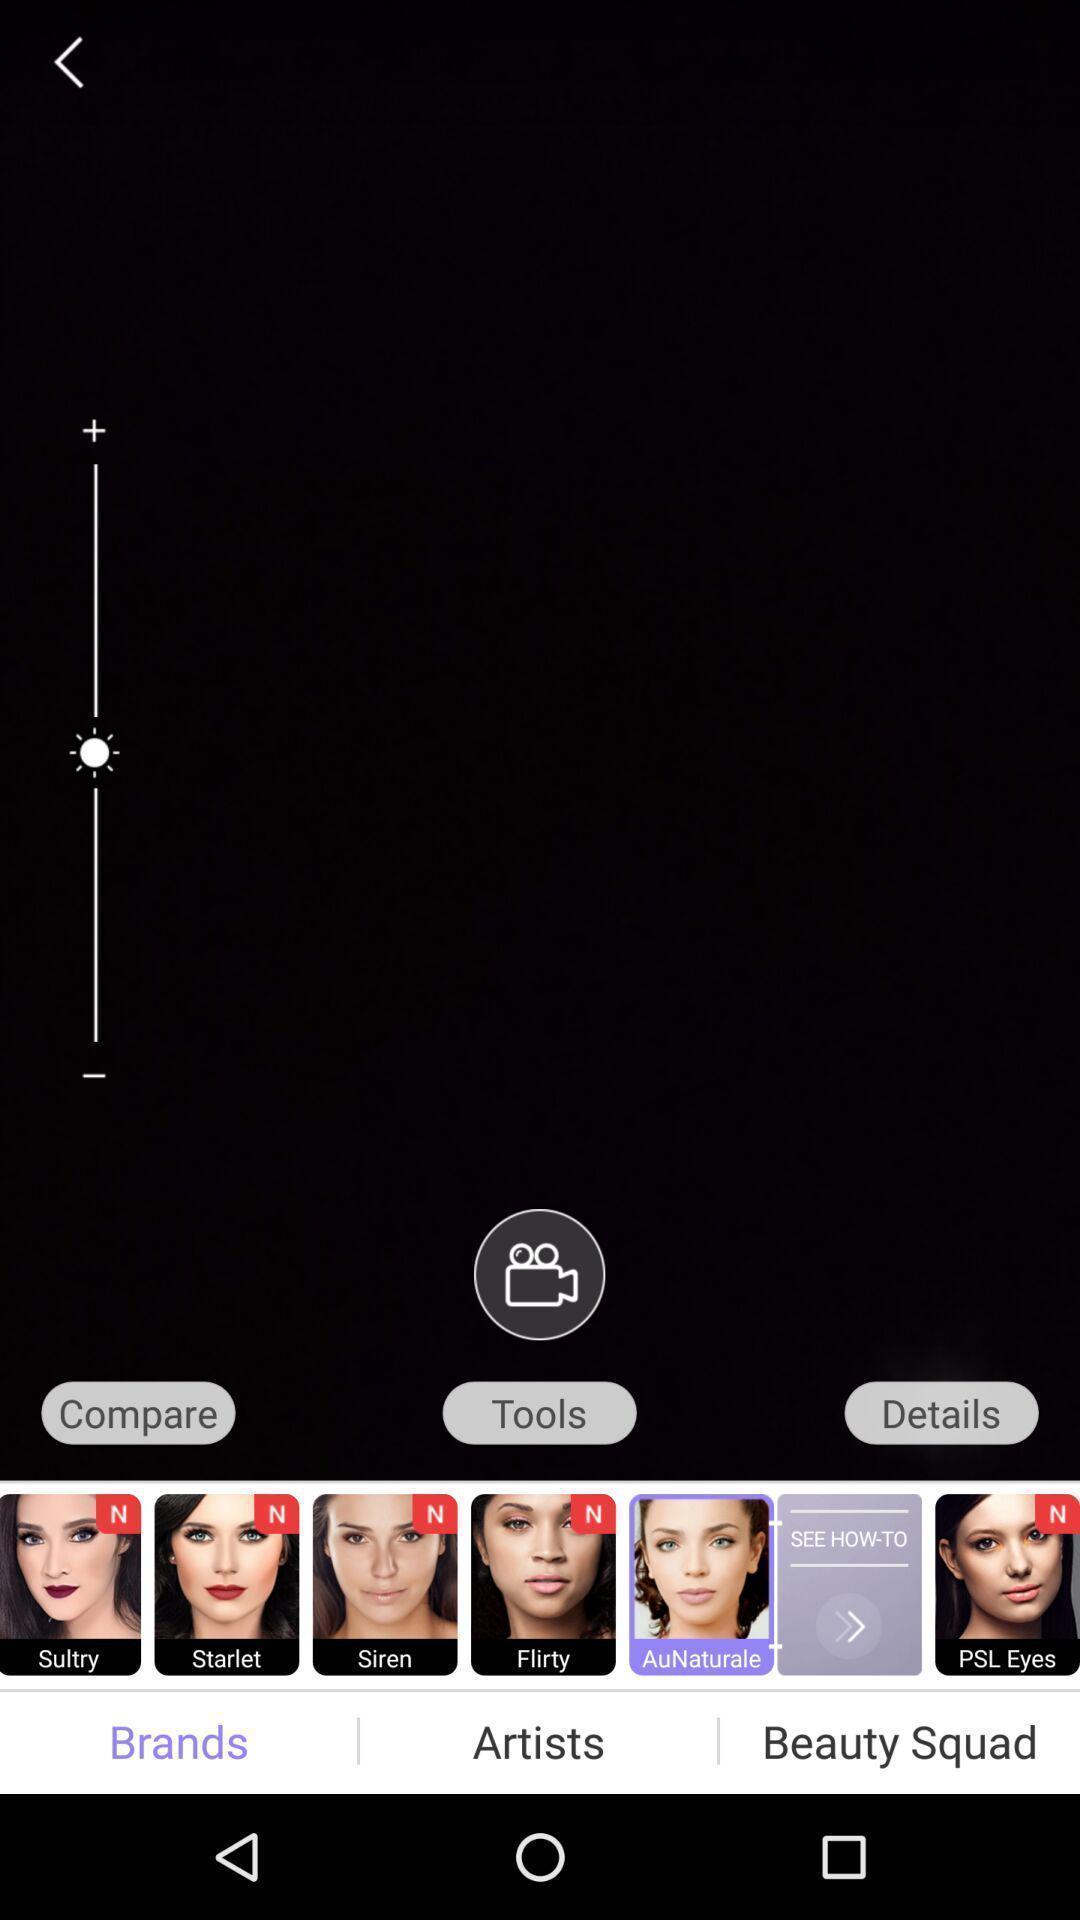Give me a summary of this screen capture. Screen displaying photo editor app. 